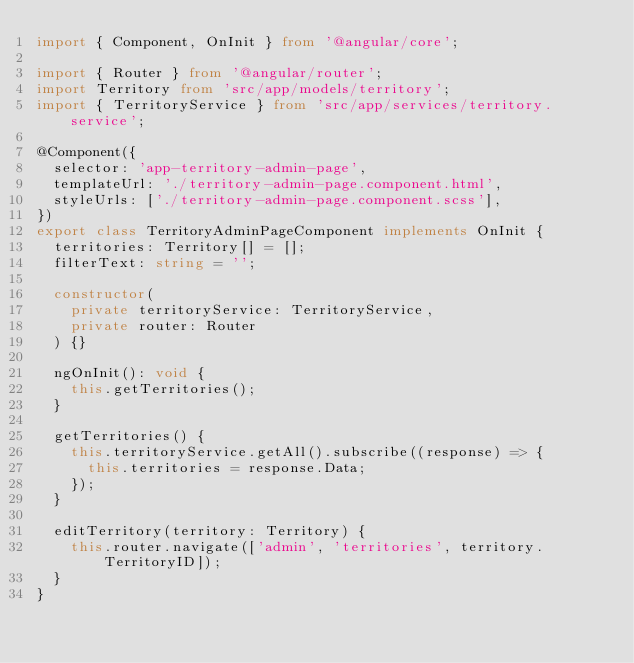Convert code to text. <code><loc_0><loc_0><loc_500><loc_500><_TypeScript_>import { Component, OnInit } from '@angular/core';

import { Router } from '@angular/router';
import Territory from 'src/app/models/territory';
import { TerritoryService } from 'src/app/services/territory.service';

@Component({
  selector: 'app-territory-admin-page',
  templateUrl: './territory-admin-page.component.html',
  styleUrls: ['./territory-admin-page.component.scss'],
})
export class TerritoryAdminPageComponent implements OnInit {
  territories: Territory[] = [];
  filterText: string = '';

  constructor(
    private territoryService: TerritoryService,
    private router: Router
  ) {}

  ngOnInit(): void {
    this.getTerritories();
  }

  getTerritories() {
    this.territoryService.getAll().subscribe((response) => {
      this.territories = response.Data;
    });
  }

  editTerritory(territory: Territory) {
    this.router.navigate(['admin', 'territories', territory.TerritoryID]);
  }
}
</code> 